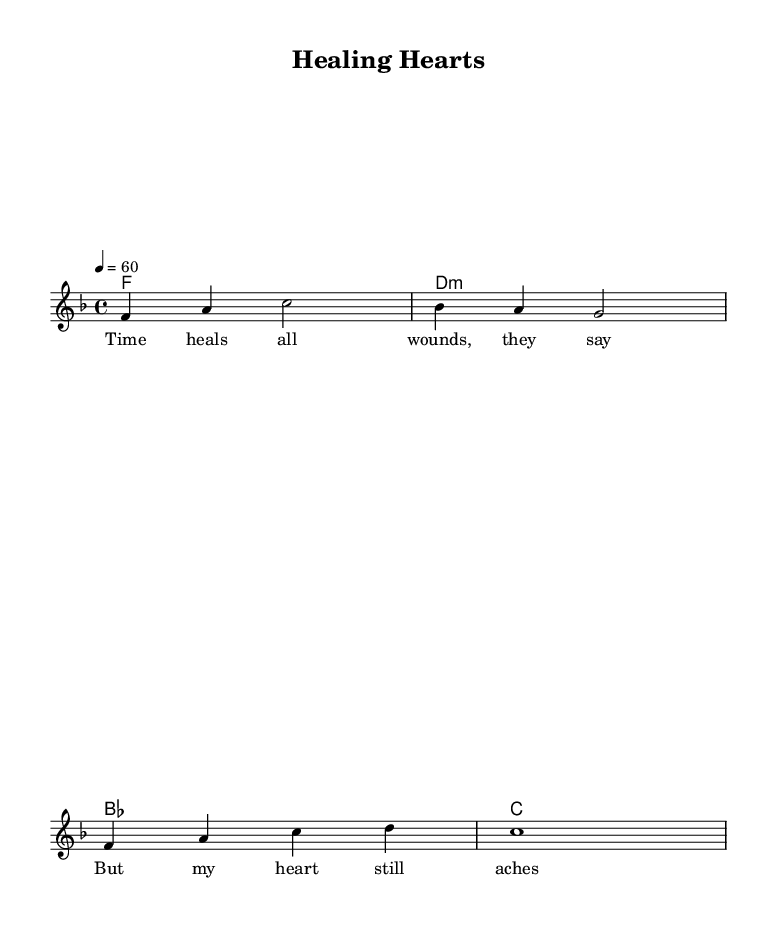What is the key signature of this music? The key signature is determined by the presence of the flat symbol, which here indicates B-flat and E-flat in the key of F major.
Answer: F major What is the time signature of this music? The time signature is indicated at the beginning of the score and shows a "4" over a "4," meaning four beats in each measure and the quarter note gets one beat.
Answer: 4/4 What tempo marking is indicated in the sheet music? The tempo marking suggests the speed of the piece, which is indicated by "4 = 60," meaning the quarter note is played at a rate of 60 beats per minute.
Answer: 60 How many measures are there in the melody section? By counting the vertical bar lines that separate the measures, there are four measures in total for the melody section.
Answer: 4 What is the last chord indicated in the harmonies section? The last chord can be identified from the chord mode, which shows the structure of the progression; it ends with a C major chord.
Answer: C What emotions do the lyrics of this ballad convey? The lyrics express longing and heartache, indicating emotional pain and reflection, typical of the soul ballad's expressive style.
Answer: Longing What unique musical element is commonly found in modern soul ballads? Modern soul ballads often feature emotive lyrics and smooth melodic lines, contributing to their emotional impact and resonance with listeners.
Answer: Emotive lyrics 